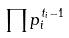Convert formula to latex. <formula><loc_0><loc_0><loc_500><loc_500>\prod p _ { i } ^ { t _ { i } - 1 }</formula> 